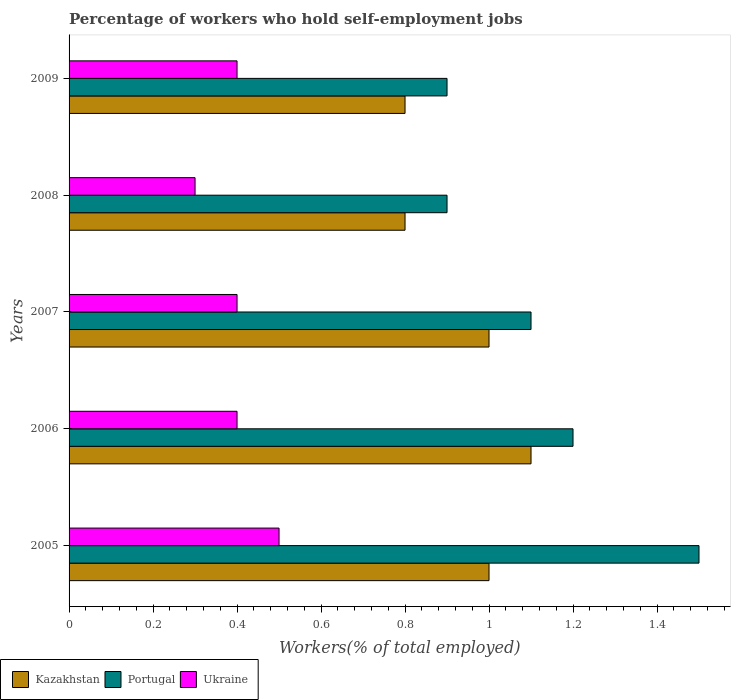How many bars are there on the 3rd tick from the bottom?
Provide a short and direct response. 3. What is the percentage of self-employed workers in Ukraine in 2007?
Give a very brief answer. 0.4. Across all years, what is the maximum percentage of self-employed workers in Portugal?
Your answer should be very brief. 1.5. Across all years, what is the minimum percentage of self-employed workers in Ukraine?
Your answer should be compact. 0.3. In which year was the percentage of self-employed workers in Ukraine minimum?
Your response must be concise. 2008. What is the total percentage of self-employed workers in Ukraine in the graph?
Your answer should be compact. 2. What is the difference between the percentage of self-employed workers in Ukraine in 2006 and the percentage of self-employed workers in Portugal in 2005?
Make the answer very short. -1.1. What is the average percentage of self-employed workers in Ukraine per year?
Give a very brief answer. 0.4. In the year 2007, what is the difference between the percentage of self-employed workers in Ukraine and percentage of self-employed workers in Portugal?
Keep it short and to the point. -0.7. In how many years, is the percentage of self-employed workers in Kazakhstan greater than 0.92 %?
Provide a succinct answer. 3. What is the ratio of the percentage of self-employed workers in Kazakhstan in 2007 to that in 2009?
Ensure brevity in your answer.  1.25. Is the difference between the percentage of self-employed workers in Ukraine in 2008 and 2009 greater than the difference between the percentage of self-employed workers in Portugal in 2008 and 2009?
Provide a succinct answer. No. What is the difference between the highest and the second highest percentage of self-employed workers in Portugal?
Your response must be concise. 0.3. What is the difference between the highest and the lowest percentage of self-employed workers in Ukraine?
Your answer should be compact. 0.2. Is the sum of the percentage of self-employed workers in Portugal in 2007 and 2008 greater than the maximum percentage of self-employed workers in Kazakhstan across all years?
Ensure brevity in your answer.  Yes. What does the 2nd bar from the top in 2006 represents?
Provide a succinct answer. Portugal. What does the 2nd bar from the bottom in 2008 represents?
Your response must be concise. Portugal. Is it the case that in every year, the sum of the percentage of self-employed workers in Kazakhstan and percentage of self-employed workers in Portugal is greater than the percentage of self-employed workers in Ukraine?
Make the answer very short. Yes. How many years are there in the graph?
Make the answer very short. 5. What is the difference between two consecutive major ticks on the X-axis?
Give a very brief answer. 0.2. Does the graph contain any zero values?
Offer a terse response. No. Where does the legend appear in the graph?
Your answer should be compact. Bottom left. How many legend labels are there?
Your response must be concise. 3. How are the legend labels stacked?
Provide a succinct answer. Horizontal. What is the title of the graph?
Keep it short and to the point. Percentage of workers who hold self-employment jobs. Does "Dominica" appear as one of the legend labels in the graph?
Make the answer very short. No. What is the label or title of the X-axis?
Offer a very short reply. Workers(% of total employed). What is the Workers(% of total employed) of Portugal in 2005?
Make the answer very short. 1.5. What is the Workers(% of total employed) in Ukraine in 2005?
Offer a terse response. 0.5. What is the Workers(% of total employed) of Kazakhstan in 2006?
Ensure brevity in your answer.  1.1. What is the Workers(% of total employed) of Portugal in 2006?
Provide a succinct answer. 1.2. What is the Workers(% of total employed) of Ukraine in 2006?
Your response must be concise. 0.4. What is the Workers(% of total employed) in Kazakhstan in 2007?
Ensure brevity in your answer.  1. What is the Workers(% of total employed) in Portugal in 2007?
Your answer should be very brief. 1.1. What is the Workers(% of total employed) of Ukraine in 2007?
Offer a very short reply. 0.4. What is the Workers(% of total employed) of Kazakhstan in 2008?
Ensure brevity in your answer.  0.8. What is the Workers(% of total employed) in Portugal in 2008?
Provide a succinct answer. 0.9. What is the Workers(% of total employed) of Ukraine in 2008?
Your answer should be compact. 0.3. What is the Workers(% of total employed) of Kazakhstan in 2009?
Give a very brief answer. 0.8. What is the Workers(% of total employed) in Portugal in 2009?
Provide a succinct answer. 0.9. What is the Workers(% of total employed) in Ukraine in 2009?
Your response must be concise. 0.4. Across all years, what is the maximum Workers(% of total employed) of Kazakhstan?
Provide a short and direct response. 1.1. Across all years, what is the maximum Workers(% of total employed) in Portugal?
Your response must be concise. 1.5. Across all years, what is the minimum Workers(% of total employed) of Kazakhstan?
Make the answer very short. 0.8. Across all years, what is the minimum Workers(% of total employed) of Portugal?
Provide a succinct answer. 0.9. Across all years, what is the minimum Workers(% of total employed) in Ukraine?
Offer a terse response. 0.3. What is the total Workers(% of total employed) of Ukraine in the graph?
Give a very brief answer. 2. What is the difference between the Workers(% of total employed) of Portugal in 2005 and that in 2006?
Your response must be concise. 0.3. What is the difference between the Workers(% of total employed) of Ukraine in 2005 and that in 2006?
Your answer should be very brief. 0.1. What is the difference between the Workers(% of total employed) in Kazakhstan in 2005 and that in 2007?
Your response must be concise. 0. What is the difference between the Workers(% of total employed) in Portugal in 2005 and that in 2007?
Your response must be concise. 0.4. What is the difference between the Workers(% of total employed) of Ukraine in 2005 and that in 2007?
Give a very brief answer. 0.1. What is the difference between the Workers(% of total employed) of Kazakhstan in 2005 and that in 2008?
Make the answer very short. 0.2. What is the difference between the Workers(% of total employed) in Portugal in 2005 and that in 2008?
Make the answer very short. 0.6. What is the difference between the Workers(% of total employed) in Portugal in 2005 and that in 2009?
Your response must be concise. 0.6. What is the difference between the Workers(% of total employed) in Portugal in 2006 and that in 2007?
Offer a terse response. 0.1. What is the difference between the Workers(% of total employed) of Kazakhstan in 2006 and that in 2008?
Your answer should be very brief. 0.3. What is the difference between the Workers(% of total employed) in Portugal in 2006 and that in 2009?
Give a very brief answer. 0.3. What is the difference between the Workers(% of total employed) in Ukraine in 2006 and that in 2009?
Provide a short and direct response. 0. What is the difference between the Workers(% of total employed) of Kazakhstan in 2007 and that in 2008?
Keep it short and to the point. 0.2. What is the difference between the Workers(% of total employed) of Portugal in 2007 and that in 2008?
Your response must be concise. 0.2. What is the difference between the Workers(% of total employed) in Ukraine in 2007 and that in 2008?
Your answer should be very brief. 0.1. What is the difference between the Workers(% of total employed) in Ukraine in 2007 and that in 2009?
Ensure brevity in your answer.  0. What is the difference between the Workers(% of total employed) in Ukraine in 2008 and that in 2009?
Keep it short and to the point. -0.1. What is the difference between the Workers(% of total employed) of Portugal in 2005 and the Workers(% of total employed) of Ukraine in 2006?
Provide a short and direct response. 1.1. What is the difference between the Workers(% of total employed) of Kazakhstan in 2005 and the Workers(% of total employed) of Portugal in 2007?
Your answer should be very brief. -0.1. What is the difference between the Workers(% of total employed) in Kazakhstan in 2005 and the Workers(% of total employed) in Ukraine in 2007?
Make the answer very short. 0.6. What is the difference between the Workers(% of total employed) of Portugal in 2005 and the Workers(% of total employed) of Ukraine in 2007?
Give a very brief answer. 1.1. What is the difference between the Workers(% of total employed) of Portugal in 2005 and the Workers(% of total employed) of Ukraine in 2008?
Keep it short and to the point. 1.2. What is the difference between the Workers(% of total employed) in Kazakhstan in 2005 and the Workers(% of total employed) in Portugal in 2009?
Provide a short and direct response. 0.1. What is the difference between the Workers(% of total employed) in Kazakhstan in 2005 and the Workers(% of total employed) in Ukraine in 2009?
Offer a terse response. 0.6. What is the difference between the Workers(% of total employed) of Portugal in 2005 and the Workers(% of total employed) of Ukraine in 2009?
Your response must be concise. 1.1. What is the difference between the Workers(% of total employed) in Portugal in 2006 and the Workers(% of total employed) in Ukraine in 2007?
Offer a very short reply. 0.8. What is the difference between the Workers(% of total employed) in Kazakhstan in 2006 and the Workers(% of total employed) in Portugal in 2008?
Give a very brief answer. 0.2. What is the difference between the Workers(% of total employed) of Kazakhstan in 2007 and the Workers(% of total employed) of Portugal in 2008?
Your answer should be compact. 0.1. What is the difference between the Workers(% of total employed) of Portugal in 2007 and the Workers(% of total employed) of Ukraine in 2008?
Make the answer very short. 0.8. What is the difference between the Workers(% of total employed) of Portugal in 2007 and the Workers(% of total employed) of Ukraine in 2009?
Offer a terse response. 0.7. What is the difference between the Workers(% of total employed) of Portugal in 2008 and the Workers(% of total employed) of Ukraine in 2009?
Keep it short and to the point. 0.5. What is the average Workers(% of total employed) in Portugal per year?
Your response must be concise. 1.12. In the year 2005, what is the difference between the Workers(% of total employed) in Kazakhstan and Workers(% of total employed) in Portugal?
Your answer should be compact. -0.5. In the year 2006, what is the difference between the Workers(% of total employed) of Kazakhstan and Workers(% of total employed) of Ukraine?
Offer a very short reply. 0.7. In the year 2006, what is the difference between the Workers(% of total employed) of Portugal and Workers(% of total employed) of Ukraine?
Offer a terse response. 0.8. In the year 2007, what is the difference between the Workers(% of total employed) of Portugal and Workers(% of total employed) of Ukraine?
Your answer should be compact. 0.7. What is the ratio of the Workers(% of total employed) in Kazakhstan in 2005 to that in 2006?
Ensure brevity in your answer.  0.91. What is the ratio of the Workers(% of total employed) in Portugal in 2005 to that in 2007?
Offer a very short reply. 1.36. What is the ratio of the Workers(% of total employed) in Kazakhstan in 2005 to that in 2009?
Provide a succinct answer. 1.25. What is the ratio of the Workers(% of total employed) of Portugal in 2006 to that in 2007?
Offer a terse response. 1.09. What is the ratio of the Workers(% of total employed) of Ukraine in 2006 to that in 2007?
Give a very brief answer. 1. What is the ratio of the Workers(% of total employed) of Kazakhstan in 2006 to that in 2008?
Ensure brevity in your answer.  1.38. What is the ratio of the Workers(% of total employed) of Kazakhstan in 2006 to that in 2009?
Provide a succinct answer. 1.38. What is the ratio of the Workers(% of total employed) of Portugal in 2006 to that in 2009?
Your response must be concise. 1.33. What is the ratio of the Workers(% of total employed) in Ukraine in 2006 to that in 2009?
Offer a very short reply. 1. What is the ratio of the Workers(% of total employed) of Kazakhstan in 2007 to that in 2008?
Ensure brevity in your answer.  1.25. What is the ratio of the Workers(% of total employed) of Portugal in 2007 to that in 2008?
Your answer should be compact. 1.22. What is the ratio of the Workers(% of total employed) of Ukraine in 2007 to that in 2008?
Offer a terse response. 1.33. What is the ratio of the Workers(% of total employed) in Portugal in 2007 to that in 2009?
Your answer should be compact. 1.22. What is the ratio of the Workers(% of total employed) of Kazakhstan in 2008 to that in 2009?
Provide a short and direct response. 1. What is the ratio of the Workers(% of total employed) in Portugal in 2008 to that in 2009?
Your answer should be very brief. 1. What is the ratio of the Workers(% of total employed) of Ukraine in 2008 to that in 2009?
Offer a terse response. 0.75. What is the difference between the highest and the second highest Workers(% of total employed) in Portugal?
Your answer should be very brief. 0.3. What is the difference between the highest and the lowest Workers(% of total employed) of Kazakhstan?
Provide a succinct answer. 0.3. 